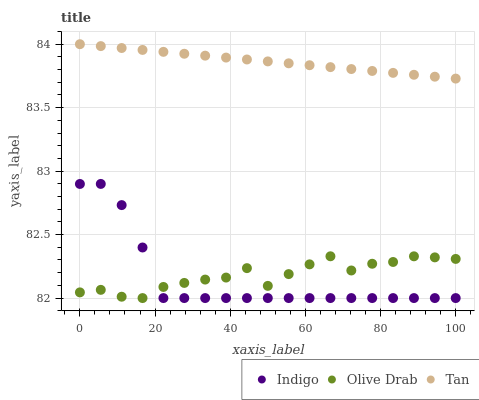Does Indigo have the minimum area under the curve?
Answer yes or no. Yes. Does Tan have the maximum area under the curve?
Answer yes or no. Yes. Does Olive Drab have the minimum area under the curve?
Answer yes or no. No. Does Olive Drab have the maximum area under the curve?
Answer yes or no. No. Is Tan the smoothest?
Answer yes or no. Yes. Is Olive Drab the roughest?
Answer yes or no. Yes. Is Indigo the smoothest?
Answer yes or no. No. Is Indigo the roughest?
Answer yes or no. No. Does Indigo have the lowest value?
Answer yes or no. Yes. Does Tan have the highest value?
Answer yes or no. Yes. Does Indigo have the highest value?
Answer yes or no. No. Is Olive Drab less than Tan?
Answer yes or no. Yes. Is Tan greater than Olive Drab?
Answer yes or no. Yes. Does Olive Drab intersect Indigo?
Answer yes or no. Yes. Is Olive Drab less than Indigo?
Answer yes or no. No. Is Olive Drab greater than Indigo?
Answer yes or no. No. Does Olive Drab intersect Tan?
Answer yes or no. No. 